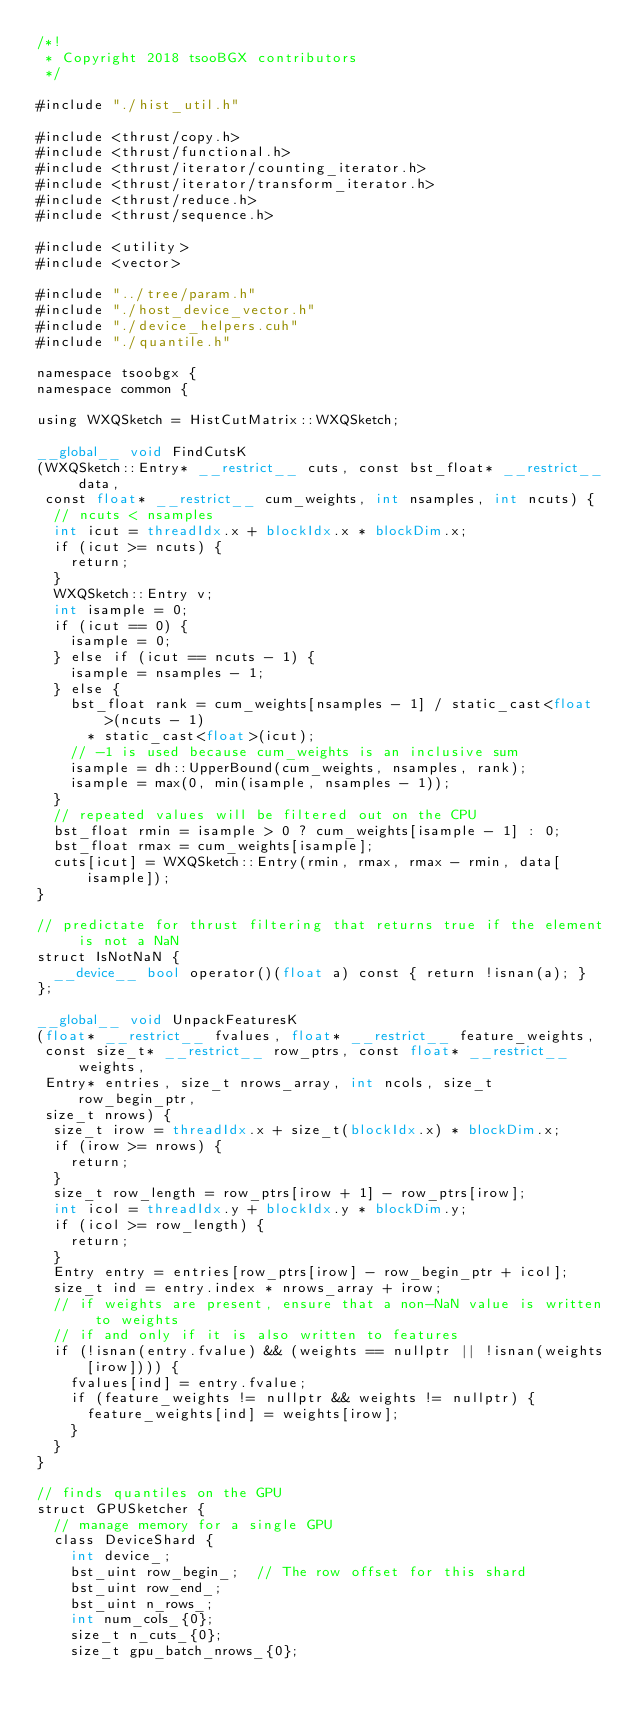<code> <loc_0><loc_0><loc_500><loc_500><_Cuda_>/*!
 * Copyright 2018 tsooBGX contributors
 */

#include "./hist_util.h"

#include <thrust/copy.h>
#include <thrust/functional.h>
#include <thrust/iterator/counting_iterator.h>
#include <thrust/iterator/transform_iterator.h>
#include <thrust/reduce.h>
#include <thrust/sequence.h>

#include <utility>
#include <vector>

#include "../tree/param.h"
#include "./host_device_vector.h"
#include "./device_helpers.cuh"
#include "./quantile.h"

namespace tsoobgx {
namespace common {

using WXQSketch = HistCutMatrix::WXQSketch;

__global__ void FindCutsK
(WXQSketch::Entry* __restrict__ cuts, const bst_float* __restrict__ data,
 const float* __restrict__ cum_weights, int nsamples, int ncuts) {
  // ncuts < nsamples
  int icut = threadIdx.x + blockIdx.x * blockDim.x;
  if (icut >= ncuts) {
    return;
  }
  WXQSketch::Entry v;
  int isample = 0;
  if (icut == 0) {
    isample = 0;
  } else if (icut == ncuts - 1) {
    isample = nsamples - 1;
  } else {
    bst_float rank = cum_weights[nsamples - 1] / static_cast<float>(ncuts - 1)
      * static_cast<float>(icut);
    // -1 is used because cum_weights is an inclusive sum
    isample = dh::UpperBound(cum_weights, nsamples, rank);
    isample = max(0, min(isample, nsamples - 1));
  }
  // repeated values will be filtered out on the CPU
  bst_float rmin = isample > 0 ? cum_weights[isample - 1] : 0;
  bst_float rmax = cum_weights[isample];
  cuts[icut] = WXQSketch::Entry(rmin, rmax, rmax - rmin, data[isample]);
}

// predictate for thrust filtering that returns true if the element is not a NaN
struct IsNotNaN {
  __device__ bool operator()(float a) const { return !isnan(a); }
};

__global__ void UnpackFeaturesK
(float* __restrict__ fvalues, float* __restrict__ feature_weights,
 const size_t* __restrict__ row_ptrs, const float* __restrict__ weights,
 Entry* entries, size_t nrows_array, int ncols, size_t row_begin_ptr,
 size_t nrows) {
  size_t irow = threadIdx.x + size_t(blockIdx.x) * blockDim.x;
  if (irow >= nrows) {
    return;
  }
  size_t row_length = row_ptrs[irow + 1] - row_ptrs[irow];
  int icol = threadIdx.y + blockIdx.y * blockDim.y;
  if (icol >= row_length) {
    return;
  }
  Entry entry = entries[row_ptrs[irow] - row_begin_ptr + icol];
  size_t ind = entry.index * nrows_array + irow;
  // if weights are present, ensure that a non-NaN value is written to weights
  // if and only if it is also written to features
  if (!isnan(entry.fvalue) && (weights == nullptr || !isnan(weights[irow]))) {
    fvalues[ind] = entry.fvalue;
    if (feature_weights != nullptr && weights != nullptr) {
      feature_weights[ind] = weights[irow];
    }
  }
}

// finds quantiles on the GPU
struct GPUSketcher {
  // manage memory for a single GPU
  class DeviceShard {
    int device_;
    bst_uint row_begin_;  // The row offset for this shard
    bst_uint row_end_;
    bst_uint n_rows_;
    int num_cols_{0};
    size_t n_cuts_{0};
    size_t gpu_batch_nrows_{0};</code> 